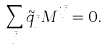<formula> <loc_0><loc_0><loc_500><loc_500>\sum _ { \bar { j } } \tilde { q } _ { \bar { j } } M ^ { i \bar { j } } = 0 .</formula> 